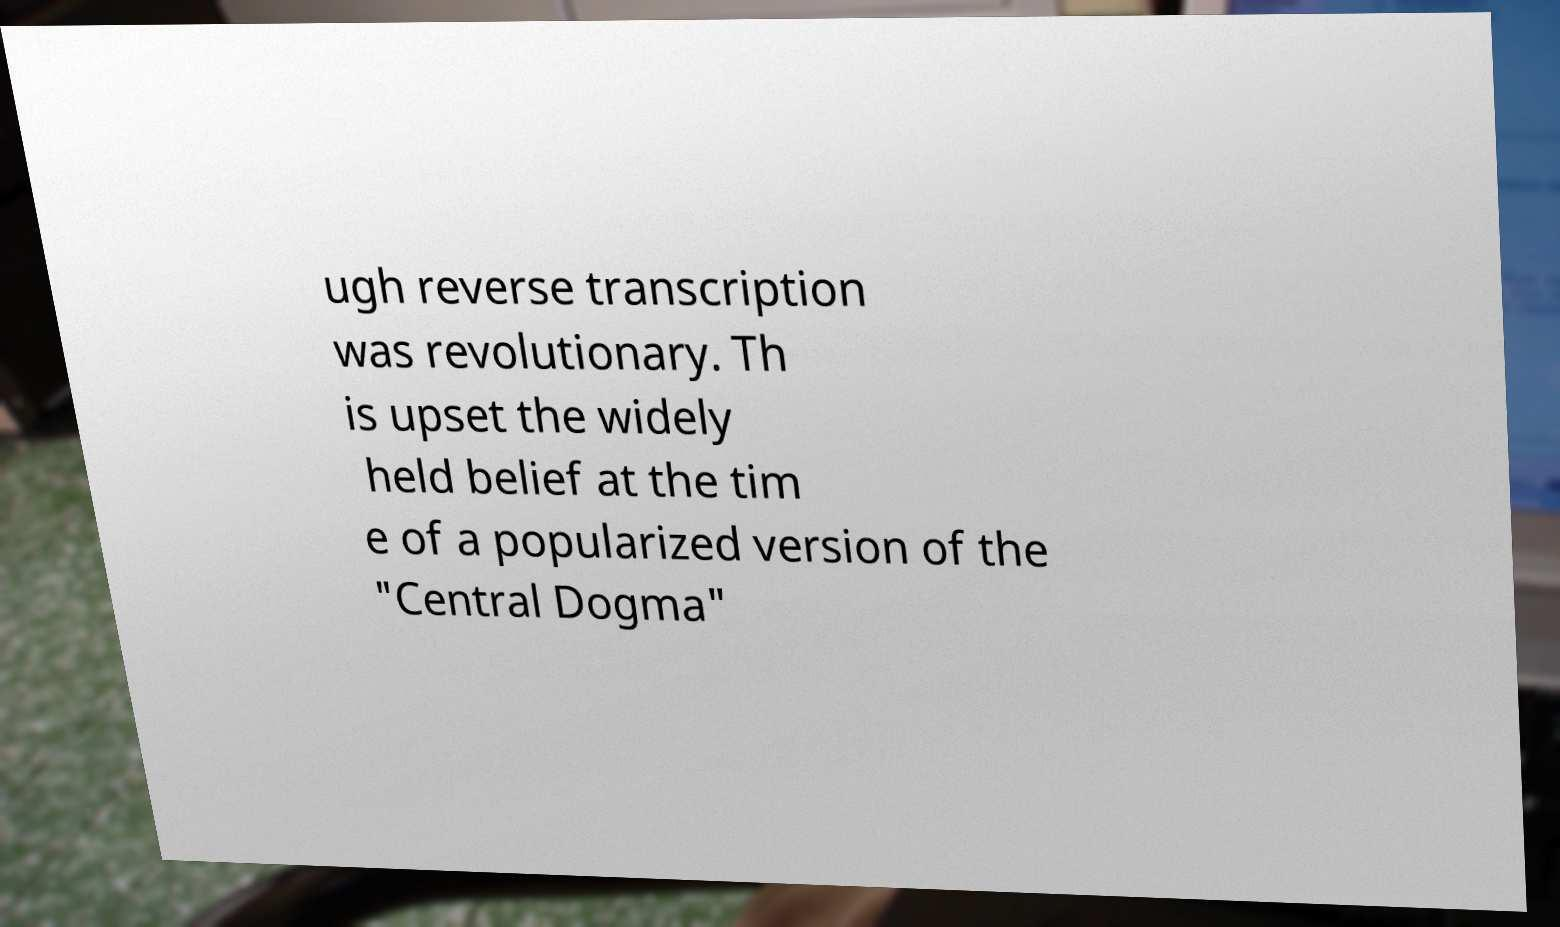Could you assist in decoding the text presented in this image and type it out clearly? ugh reverse transcription was revolutionary. Th is upset the widely held belief at the tim e of a popularized version of the "Central Dogma" 